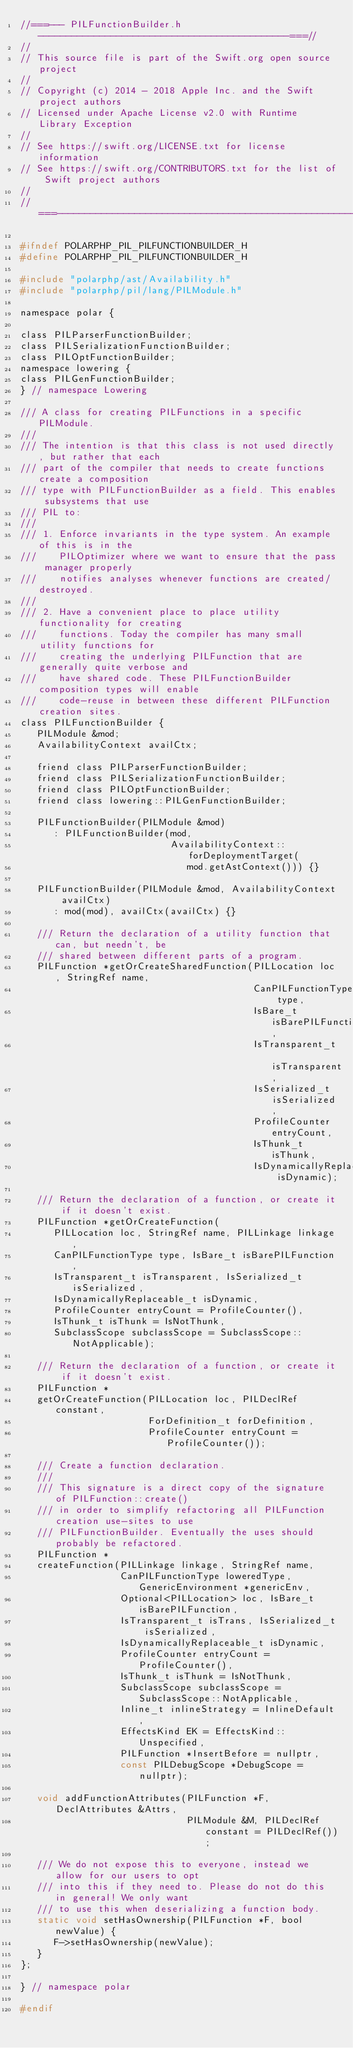Convert code to text. <code><loc_0><loc_0><loc_500><loc_500><_C_>//===--- PILFunctionBuilder.h ---------------------------------------------===//
//
// This source file is part of the Swift.org open source project
//
// Copyright (c) 2014 - 2018 Apple Inc. and the Swift project authors
// Licensed under Apache License v2.0 with Runtime Library Exception
//
// See https://swift.org/LICENSE.txt for license information
// See https://swift.org/CONTRIBUTORS.txt for the list of Swift project authors
//
//===----------------------------------------------------------------------===//

#ifndef POLARPHP_PIL_PILFUNCTIONBUILDER_H
#define POLARPHP_PIL_PILFUNCTIONBUILDER_H

#include "polarphp/ast/Availability.h"
#include "polarphp/pil/lang/PILModule.h"

namespace polar {

class PILParserFunctionBuilder;
class PILSerializationFunctionBuilder;
class PILOptFunctionBuilder;
namespace lowering {
class PILGenFunctionBuilder;
} // namespace Lowering

/// A class for creating PILFunctions in a specific PILModule.
///
/// The intention is that this class is not used directly, but rather that each
/// part of the compiler that needs to create functions create a composition
/// type with PILFunctionBuilder as a field. This enables subsystems that use
/// PIL to:
///
/// 1. Enforce invariants in the type system. An example of this is in the
///    PILOptimizer where we want to ensure that the pass manager properly
///    notifies analyses whenever functions are created/destroyed.
///
/// 2. Have a convenient place to place utility functionality for creating
///    functions. Today the compiler has many small utility functions for
///    creating the underlying PILFunction that are generally quite verbose and
///    have shared code. These PILFunctionBuilder composition types will enable
///    code-reuse in between these different PILFunction creation sites.
class PILFunctionBuilder {
   PILModule &mod;
   AvailabilityContext availCtx;

   friend class PILParserFunctionBuilder;
   friend class PILSerializationFunctionBuilder;
   friend class PILOptFunctionBuilder;
   friend class lowering::PILGenFunctionBuilder;

   PILFunctionBuilder(PILModule &mod)
      : PILFunctionBuilder(mod,
                           AvailabilityContext::forDeploymentTarget(
                              mod.getAstContext())) {}

   PILFunctionBuilder(PILModule &mod, AvailabilityContext availCtx)
      : mod(mod), availCtx(availCtx) {}

   /// Return the declaration of a utility function that can, but needn't, be
   /// shared between different parts of a program.
   PILFunction *getOrCreateSharedFunction(PILLocation loc, StringRef name,
                                          CanPILFunctionType type,
                                          IsBare_t isBarePILFunction,
                                          IsTransparent_t isTransparent,
                                          IsSerialized_t isSerialized,
                                          ProfileCounter entryCount,
                                          IsThunk_t isThunk,
                                          IsDynamicallyReplaceable_t isDynamic);

   /// Return the declaration of a function, or create it if it doesn't exist.
   PILFunction *getOrCreateFunction(
      PILLocation loc, StringRef name, PILLinkage linkage,
      CanPILFunctionType type, IsBare_t isBarePILFunction,
      IsTransparent_t isTransparent, IsSerialized_t isSerialized,
      IsDynamicallyReplaceable_t isDynamic,
      ProfileCounter entryCount = ProfileCounter(),
      IsThunk_t isThunk = IsNotThunk,
      SubclassScope subclassScope = SubclassScope::NotApplicable);

   /// Return the declaration of a function, or create it if it doesn't exist.
   PILFunction *
   getOrCreateFunction(PILLocation loc, PILDeclRef constant,
                       ForDefinition_t forDefinition,
                       ProfileCounter entryCount = ProfileCounter());

   /// Create a function declaration.
   ///
   /// This signature is a direct copy of the signature of PILFunction::create()
   /// in order to simplify refactoring all PILFunction creation use-sites to use
   /// PILFunctionBuilder. Eventually the uses should probably be refactored.
   PILFunction *
   createFunction(PILLinkage linkage, StringRef name,
                  CanPILFunctionType loweredType, GenericEnvironment *genericEnv,
                  Optional<PILLocation> loc, IsBare_t isBarePILFunction,
                  IsTransparent_t isTrans, IsSerialized_t isSerialized,
                  IsDynamicallyReplaceable_t isDynamic,
                  ProfileCounter entryCount = ProfileCounter(),
                  IsThunk_t isThunk = IsNotThunk,
                  SubclassScope subclassScope = SubclassScope::NotApplicable,
                  Inline_t inlineStrategy = InlineDefault,
                  EffectsKind EK = EffectsKind::Unspecified,
                  PILFunction *InsertBefore = nullptr,
                  const PILDebugScope *DebugScope = nullptr);

   void addFunctionAttributes(PILFunction *F, DeclAttributes &Attrs,
                              PILModule &M, PILDeclRef constant = PILDeclRef());

   /// We do not expose this to everyone, instead we allow for our users to opt
   /// into this if they need to. Please do not do this in general! We only want
   /// to use this when deserializing a function body.
   static void setHasOwnership(PILFunction *F, bool newValue) {
      F->setHasOwnership(newValue);
   }
};

} // namespace polar

#endif
</code> 